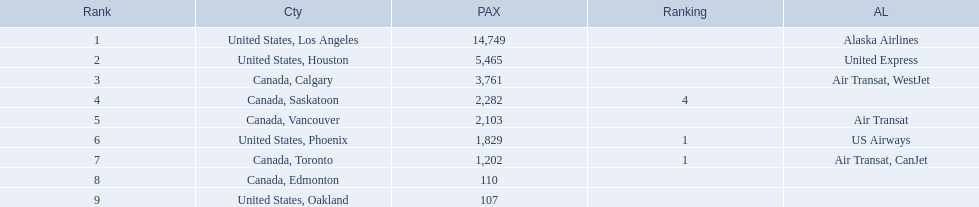Help me parse the entirety of this table. {'header': ['Rank', 'Cty', 'PAX', 'Ranking', 'AL'], 'rows': [['1', 'United States, Los Angeles', '14,749', '', 'Alaska Airlines'], ['2', 'United States, Houston', '5,465', '', 'United Express'], ['3', 'Canada, Calgary', '3,761', '', 'Air Transat, WestJet'], ['4', 'Canada, Saskatoon', '2,282', '4', ''], ['5', 'Canada, Vancouver', '2,103', '', 'Air Transat'], ['6', 'United States, Phoenix', '1,829', '1', 'US Airways'], ['7', 'Canada, Toronto', '1,202', '1', 'Air Transat, CanJet'], ['8', 'Canada, Edmonton', '110', '', ''], ['9', 'United States, Oakland', '107', '', '']]} What cities do the planes fly to? United States, Los Angeles, United States, Houston, Canada, Calgary, Canada, Saskatoon, Canada, Vancouver, United States, Phoenix, Canada, Toronto, Canada, Edmonton, United States, Oakland. How many people are flying to phoenix, arizona? 1,829. 